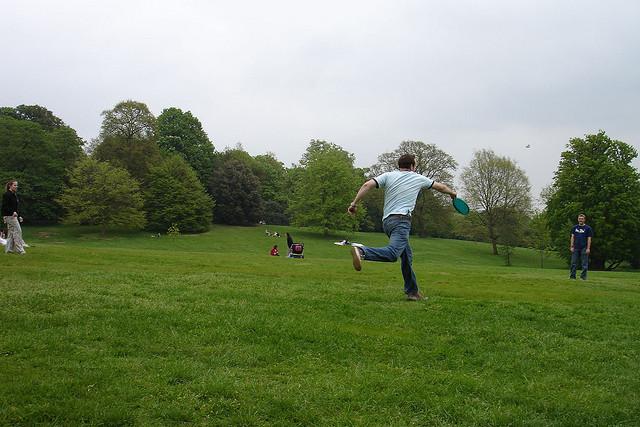What are these people playing?
Concise answer only. Frisbee. Is there a body of water in this picture?
Short answer required. No. Is the person in the photo moving briskly or standing still?
Give a very brief answer. Moving briskly. How many street lights are in the picture?
Be succinct. 0. Are there many small trees?
Give a very brief answer. Yes. Are they holding parasols?
Write a very short answer. No. Where is the frisbee?
Short answer required. Man's hand. What color is the person's shirt?
Short answer required. White. Are there any signs prohibiting behavior?
Write a very short answer. No. Are these people in a forest?
Short answer required. No. Are there tents in the background?
Keep it brief. No. Is the sky clear?
Answer briefly. No. What color is the frisbee?
Write a very short answer. Green. How many trees are shown?
Short answer required. 11. Why is he running?
Short answer required. Playing frisbee. Is the man wearing a hat?
Concise answer only. No. What color is the horse?
Be succinct. No horse. What is the man wearing?
Be succinct. Jeans. 